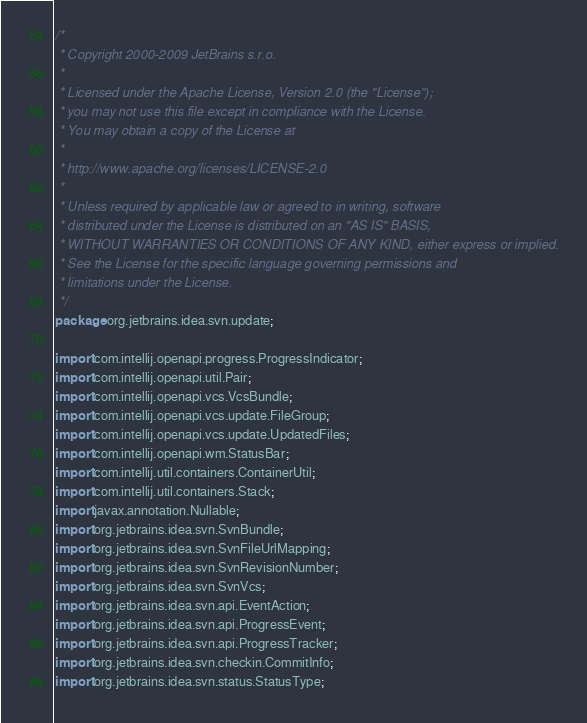Convert code to text. <code><loc_0><loc_0><loc_500><loc_500><_Java_>/*
 * Copyright 2000-2009 JetBrains s.r.o.
 *
 * Licensed under the Apache License, Version 2.0 (the "License");
 * you may not use this file except in compliance with the License.
 * You may obtain a copy of the License at
 *
 * http://www.apache.org/licenses/LICENSE-2.0
 *
 * Unless required by applicable law or agreed to in writing, software
 * distributed under the License is distributed on an "AS IS" BASIS,
 * WITHOUT WARRANTIES OR CONDITIONS OF ANY KIND, either express or implied.
 * See the License for the specific language governing permissions and
 * limitations under the License.
 */
package org.jetbrains.idea.svn.update;

import com.intellij.openapi.progress.ProgressIndicator;
import com.intellij.openapi.util.Pair;
import com.intellij.openapi.vcs.VcsBundle;
import com.intellij.openapi.vcs.update.FileGroup;
import com.intellij.openapi.vcs.update.UpdatedFiles;
import com.intellij.openapi.wm.StatusBar;
import com.intellij.util.containers.ContainerUtil;
import com.intellij.util.containers.Stack;
import javax.annotation.Nullable;
import org.jetbrains.idea.svn.SvnBundle;
import org.jetbrains.idea.svn.SvnFileUrlMapping;
import org.jetbrains.idea.svn.SvnRevisionNumber;
import org.jetbrains.idea.svn.SvnVcs;
import org.jetbrains.idea.svn.api.EventAction;
import org.jetbrains.idea.svn.api.ProgressEvent;
import org.jetbrains.idea.svn.api.ProgressTracker;
import org.jetbrains.idea.svn.checkin.CommitInfo;
import org.jetbrains.idea.svn.status.StatusType;</code> 